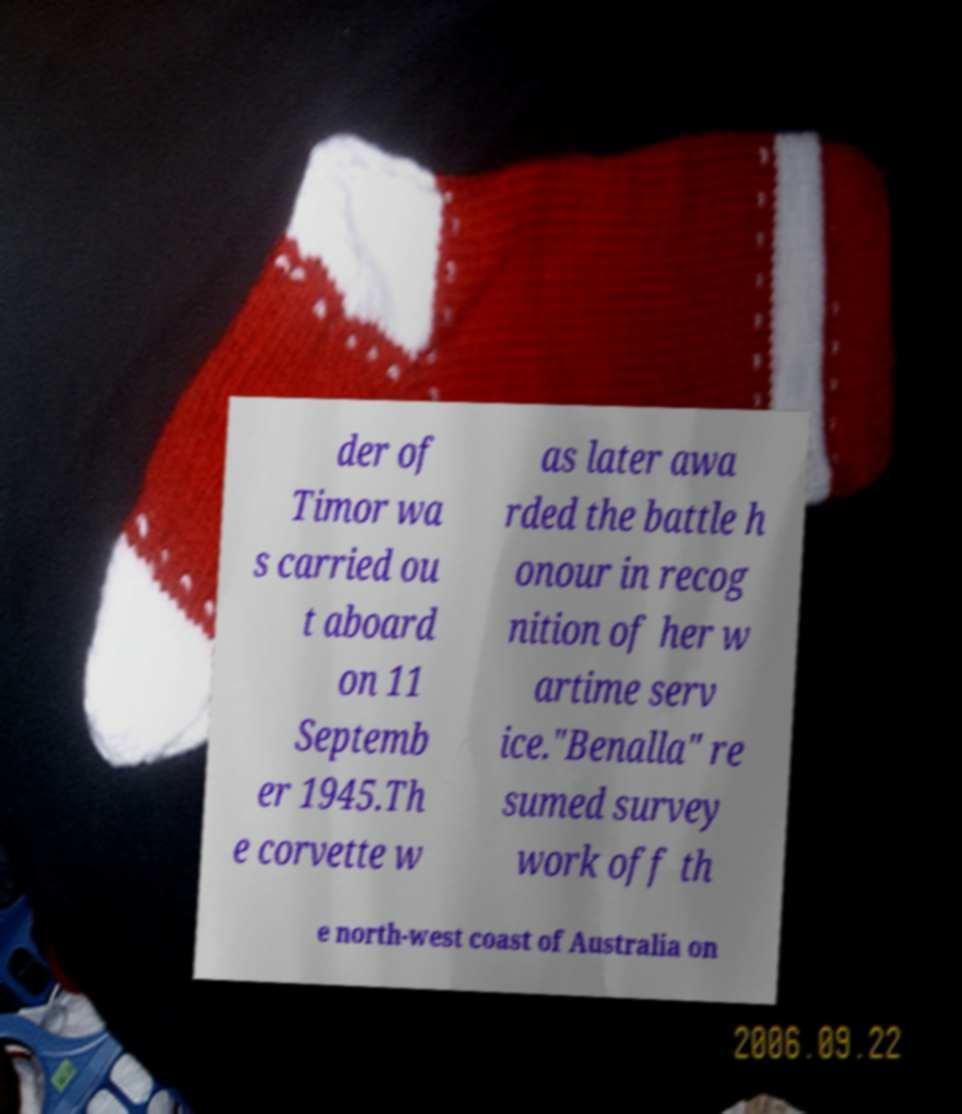For documentation purposes, I need the text within this image transcribed. Could you provide that? der of Timor wa s carried ou t aboard on 11 Septemb er 1945.Th e corvette w as later awa rded the battle h onour in recog nition of her w artime serv ice."Benalla" re sumed survey work off th e north-west coast of Australia on 